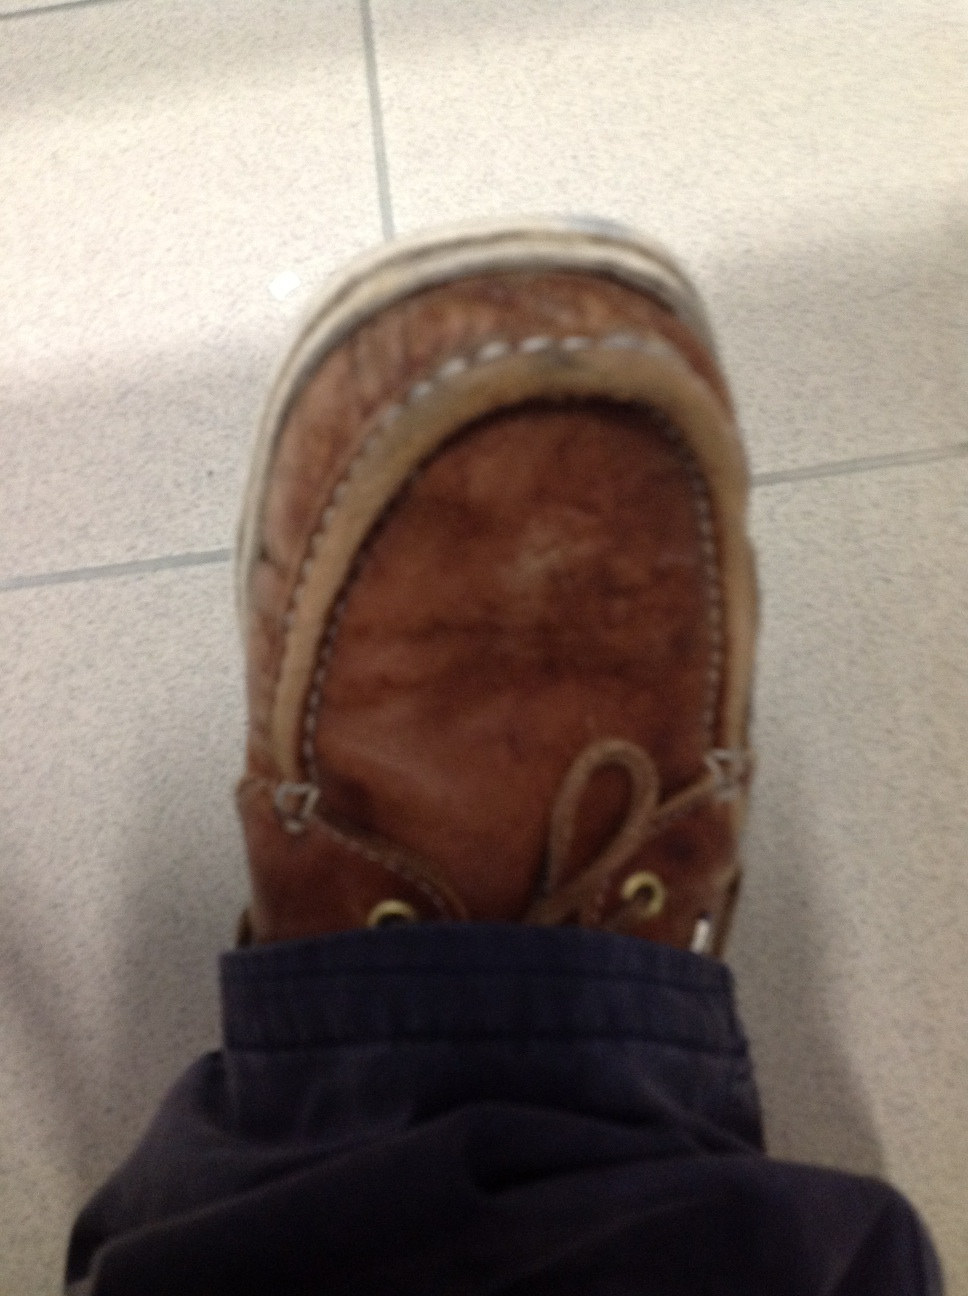Can you describe the material of this shoe? The shoe in the image appears to be made of brown leather, a material known for its durability and classic style. It has a rugged texture, suggesting it has been used quite frequently, adding a vintage charm to it. What kind of occasion would this shoe be appropriate for? This brown leather loafer is perfect for casual and semi-formal occasions. It could be worn to a casual office environment, a relaxed evening out, or even a family gathering. Its versatile style can complement a range of outfits from jeans to casual trousers. 